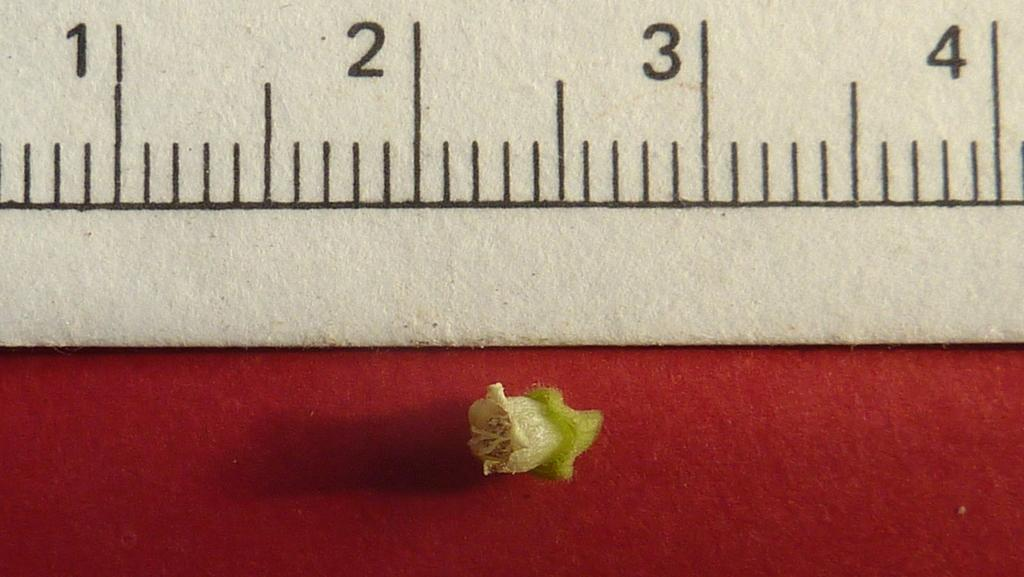What is the main object in the image? There is a scale in the image. Can you describe the secondary object in the image? There is a bud at the bottom of the image. What type of tin can be seen in the image? There is no tin present in the image. How many weeks are depicted in the image? The image does not show any weeks; it features a scale and a bud. 